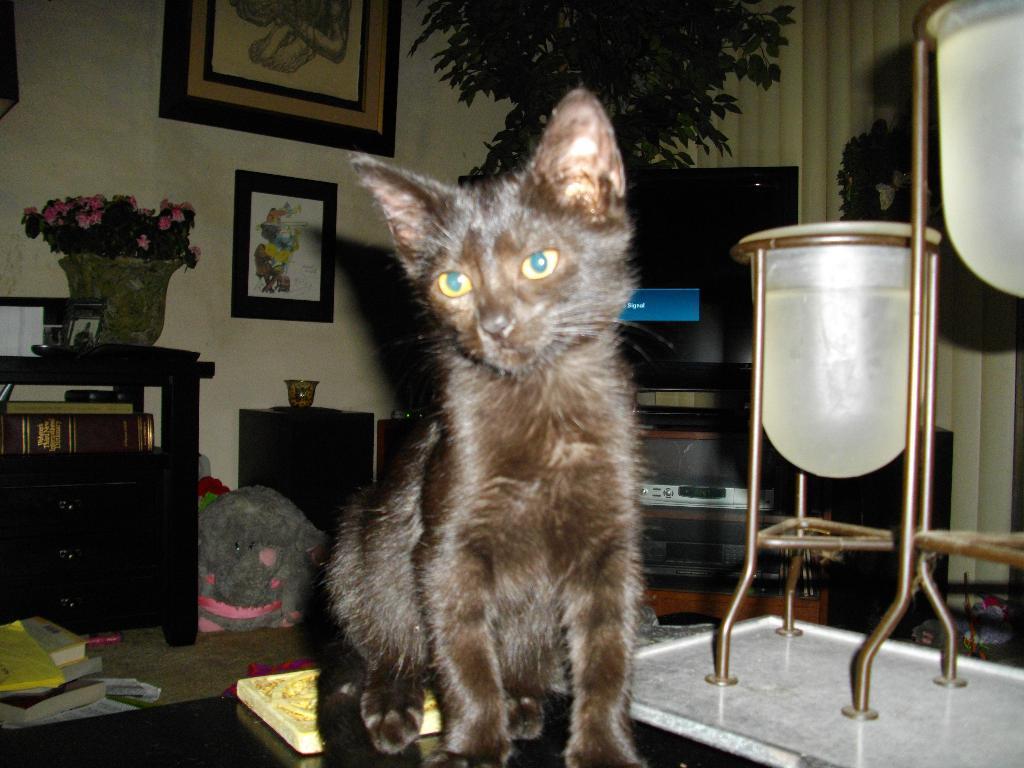Describe this image in one or two sentences. This image is clicked inside a room. In this image, there is a cat in black color sitting in the front. In the background there is a wall on which two frames are fixed. To the left there is a small table on which a plant is kept. To the right, there is a TV along with TV stand. 